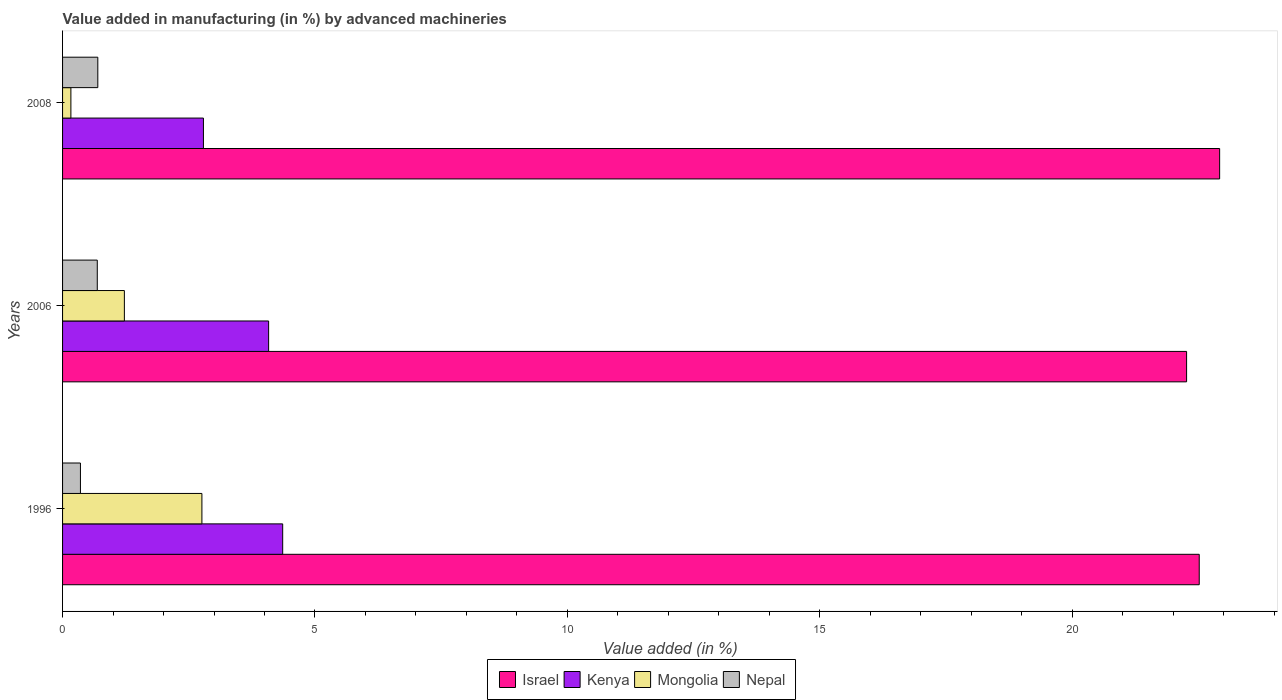How many groups of bars are there?
Your answer should be compact. 3. In how many cases, is the number of bars for a given year not equal to the number of legend labels?
Make the answer very short. 0. What is the percentage of value added in manufacturing by advanced machineries in Kenya in 2006?
Provide a short and direct response. 4.08. Across all years, what is the maximum percentage of value added in manufacturing by advanced machineries in Mongolia?
Your answer should be very brief. 2.76. Across all years, what is the minimum percentage of value added in manufacturing by advanced machineries in Mongolia?
Provide a succinct answer. 0.17. What is the total percentage of value added in manufacturing by advanced machineries in Mongolia in the graph?
Make the answer very short. 4.15. What is the difference between the percentage of value added in manufacturing by advanced machineries in Nepal in 1996 and that in 2006?
Ensure brevity in your answer.  -0.33. What is the difference between the percentage of value added in manufacturing by advanced machineries in Kenya in 1996 and the percentage of value added in manufacturing by advanced machineries in Nepal in 2008?
Your answer should be compact. 3.66. What is the average percentage of value added in manufacturing by advanced machineries in Mongolia per year?
Your answer should be very brief. 1.38. In the year 1996, what is the difference between the percentage of value added in manufacturing by advanced machineries in Israel and percentage of value added in manufacturing by advanced machineries in Kenya?
Provide a short and direct response. 18.16. What is the ratio of the percentage of value added in manufacturing by advanced machineries in Mongolia in 1996 to that in 2006?
Your answer should be very brief. 2.25. What is the difference between the highest and the second highest percentage of value added in manufacturing by advanced machineries in Nepal?
Your response must be concise. 0.01. What is the difference between the highest and the lowest percentage of value added in manufacturing by advanced machineries in Mongolia?
Your answer should be compact. 2.6. Is the sum of the percentage of value added in manufacturing by advanced machineries in Israel in 1996 and 2006 greater than the maximum percentage of value added in manufacturing by advanced machineries in Mongolia across all years?
Your response must be concise. Yes. What does the 1st bar from the top in 1996 represents?
Provide a short and direct response. Nepal. What does the 2nd bar from the bottom in 2006 represents?
Keep it short and to the point. Kenya. How many bars are there?
Provide a short and direct response. 12. Are all the bars in the graph horizontal?
Ensure brevity in your answer.  Yes. What is the difference between two consecutive major ticks on the X-axis?
Offer a terse response. 5. How many legend labels are there?
Your answer should be very brief. 4. What is the title of the graph?
Provide a short and direct response. Value added in manufacturing (in %) by advanced machineries. Does "Heavily indebted poor countries" appear as one of the legend labels in the graph?
Offer a terse response. No. What is the label or title of the X-axis?
Offer a terse response. Value added (in %). What is the Value added (in %) of Israel in 1996?
Provide a succinct answer. 22.52. What is the Value added (in %) in Kenya in 1996?
Your response must be concise. 4.36. What is the Value added (in %) of Mongolia in 1996?
Keep it short and to the point. 2.76. What is the Value added (in %) in Nepal in 1996?
Provide a succinct answer. 0.35. What is the Value added (in %) in Israel in 2006?
Provide a succinct answer. 22.27. What is the Value added (in %) in Kenya in 2006?
Provide a short and direct response. 4.08. What is the Value added (in %) of Mongolia in 2006?
Ensure brevity in your answer.  1.22. What is the Value added (in %) of Nepal in 2006?
Ensure brevity in your answer.  0.69. What is the Value added (in %) of Israel in 2008?
Offer a very short reply. 22.92. What is the Value added (in %) of Kenya in 2008?
Offer a terse response. 2.79. What is the Value added (in %) in Mongolia in 2008?
Offer a very short reply. 0.17. What is the Value added (in %) of Nepal in 2008?
Provide a short and direct response. 0.7. Across all years, what is the maximum Value added (in %) of Israel?
Keep it short and to the point. 22.92. Across all years, what is the maximum Value added (in %) in Kenya?
Your response must be concise. 4.36. Across all years, what is the maximum Value added (in %) in Mongolia?
Provide a short and direct response. 2.76. Across all years, what is the maximum Value added (in %) of Nepal?
Keep it short and to the point. 0.7. Across all years, what is the minimum Value added (in %) of Israel?
Ensure brevity in your answer.  22.27. Across all years, what is the minimum Value added (in %) in Kenya?
Your response must be concise. 2.79. Across all years, what is the minimum Value added (in %) in Mongolia?
Make the answer very short. 0.17. Across all years, what is the minimum Value added (in %) of Nepal?
Your answer should be very brief. 0.35. What is the total Value added (in %) in Israel in the graph?
Keep it short and to the point. 67.71. What is the total Value added (in %) in Kenya in the graph?
Your answer should be compact. 11.23. What is the total Value added (in %) of Mongolia in the graph?
Provide a succinct answer. 4.15. What is the total Value added (in %) of Nepal in the graph?
Your answer should be very brief. 1.74. What is the difference between the Value added (in %) in Israel in 1996 and that in 2006?
Your response must be concise. 0.25. What is the difference between the Value added (in %) in Kenya in 1996 and that in 2006?
Offer a terse response. 0.28. What is the difference between the Value added (in %) of Mongolia in 1996 and that in 2006?
Give a very brief answer. 1.54. What is the difference between the Value added (in %) of Nepal in 1996 and that in 2006?
Your response must be concise. -0.33. What is the difference between the Value added (in %) of Israel in 1996 and that in 2008?
Offer a very short reply. -0.4. What is the difference between the Value added (in %) of Kenya in 1996 and that in 2008?
Your answer should be compact. 1.57. What is the difference between the Value added (in %) of Mongolia in 1996 and that in 2008?
Provide a short and direct response. 2.6. What is the difference between the Value added (in %) of Nepal in 1996 and that in 2008?
Offer a very short reply. -0.34. What is the difference between the Value added (in %) of Israel in 2006 and that in 2008?
Your response must be concise. -0.65. What is the difference between the Value added (in %) of Kenya in 2006 and that in 2008?
Provide a succinct answer. 1.29. What is the difference between the Value added (in %) in Mongolia in 2006 and that in 2008?
Provide a succinct answer. 1.06. What is the difference between the Value added (in %) of Nepal in 2006 and that in 2008?
Ensure brevity in your answer.  -0.01. What is the difference between the Value added (in %) of Israel in 1996 and the Value added (in %) of Kenya in 2006?
Provide a succinct answer. 18.44. What is the difference between the Value added (in %) of Israel in 1996 and the Value added (in %) of Mongolia in 2006?
Provide a succinct answer. 21.29. What is the difference between the Value added (in %) in Israel in 1996 and the Value added (in %) in Nepal in 2006?
Your answer should be very brief. 21.83. What is the difference between the Value added (in %) of Kenya in 1996 and the Value added (in %) of Mongolia in 2006?
Make the answer very short. 3.14. What is the difference between the Value added (in %) in Kenya in 1996 and the Value added (in %) in Nepal in 2006?
Make the answer very short. 3.67. What is the difference between the Value added (in %) of Mongolia in 1996 and the Value added (in %) of Nepal in 2006?
Make the answer very short. 2.07. What is the difference between the Value added (in %) in Israel in 1996 and the Value added (in %) in Kenya in 2008?
Provide a short and direct response. 19.73. What is the difference between the Value added (in %) of Israel in 1996 and the Value added (in %) of Mongolia in 2008?
Make the answer very short. 22.35. What is the difference between the Value added (in %) of Israel in 1996 and the Value added (in %) of Nepal in 2008?
Keep it short and to the point. 21.82. What is the difference between the Value added (in %) in Kenya in 1996 and the Value added (in %) in Mongolia in 2008?
Provide a short and direct response. 4.2. What is the difference between the Value added (in %) of Kenya in 1996 and the Value added (in %) of Nepal in 2008?
Your response must be concise. 3.66. What is the difference between the Value added (in %) of Mongolia in 1996 and the Value added (in %) of Nepal in 2008?
Your answer should be very brief. 2.06. What is the difference between the Value added (in %) in Israel in 2006 and the Value added (in %) in Kenya in 2008?
Ensure brevity in your answer.  19.48. What is the difference between the Value added (in %) of Israel in 2006 and the Value added (in %) of Mongolia in 2008?
Your response must be concise. 22.1. What is the difference between the Value added (in %) of Israel in 2006 and the Value added (in %) of Nepal in 2008?
Offer a very short reply. 21.57. What is the difference between the Value added (in %) of Kenya in 2006 and the Value added (in %) of Mongolia in 2008?
Your response must be concise. 3.92. What is the difference between the Value added (in %) of Kenya in 2006 and the Value added (in %) of Nepal in 2008?
Your answer should be compact. 3.38. What is the difference between the Value added (in %) in Mongolia in 2006 and the Value added (in %) in Nepal in 2008?
Your answer should be very brief. 0.53. What is the average Value added (in %) in Israel per year?
Your answer should be compact. 22.57. What is the average Value added (in %) in Kenya per year?
Your answer should be compact. 3.74. What is the average Value added (in %) of Mongolia per year?
Make the answer very short. 1.38. What is the average Value added (in %) in Nepal per year?
Your answer should be very brief. 0.58. In the year 1996, what is the difference between the Value added (in %) of Israel and Value added (in %) of Kenya?
Provide a short and direct response. 18.16. In the year 1996, what is the difference between the Value added (in %) of Israel and Value added (in %) of Mongolia?
Offer a very short reply. 19.76. In the year 1996, what is the difference between the Value added (in %) in Israel and Value added (in %) in Nepal?
Your response must be concise. 22.16. In the year 1996, what is the difference between the Value added (in %) in Kenya and Value added (in %) in Mongolia?
Your answer should be compact. 1.6. In the year 1996, what is the difference between the Value added (in %) of Kenya and Value added (in %) of Nepal?
Keep it short and to the point. 4.01. In the year 1996, what is the difference between the Value added (in %) of Mongolia and Value added (in %) of Nepal?
Make the answer very short. 2.41. In the year 2006, what is the difference between the Value added (in %) in Israel and Value added (in %) in Kenya?
Make the answer very short. 18.19. In the year 2006, what is the difference between the Value added (in %) of Israel and Value added (in %) of Mongolia?
Provide a short and direct response. 21.04. In the year 2006, what is the difference between the Value added (in %) of Israel and Value added (in %) of Nepal?
Offer a very short reply. 21.58. In the year 2006, what is the difference between the Value added (in %) of Kenya and Value added (in %) of Mongolia?
Provide a short and direct response. 2.86. In the year 2006, what is the difference between the Value added (in %) of Kenya and Value added (in %) of Nepal?
Your answer should be very brief. 3.39. In the year 2006, what is the difference between the Value added (in %) in Mongolia and Value added (in %) in Nepal?
Your response must be concise. 0.54. In the year 2008, what is the difference between the Value added (in %) of Israel and Value added (in %) of Kenya?
Your answer should be very brief. 20.13. In the year 2008, what is the difference between the Value added (in %) in Israel and Value added (in %) in Mongolia?
Make the answer very short. 22.76. In the year 2008, what is the difference between the Value added (in %) of Israel and Value added (in %) of Nepal?
Offer a terse response. 22.22. In the year 2008, what is the difference between the Value added (in %) in Kenya and Value added (in %) in Mongolia?
Give a very brief answer. 2.63. In the year 2008, what is the difference between the Value added (in %) of Kenya and Value added (in %) of Nepal?
Make the answer very short. 2.09. In the year 2008, what is the difference between the Value added (in %) in Mongolia and Value added (in %) in Nepal?
Offer a terse response. -0.53. What is the ratio of the Value added (in %) in Israel in 1996 to that in 2006?
Your answer should be compact. 1.01. What is the ratio of the Value added (in %) in Kenya in 1996 to that in 2006?
Provide a short and direct response. 1.07. What is the ratio of the Value added (in %) in Mongolia in 1996 to that in 2006?
Offer a very short reply. 2.25. What is the ratio of the Value added (in %) of Nepal in 1996 to that in 2006?
Your answer should be very brief. 0.51. What is the ratio of the Value added (in %) in Israel in 1996 to that in 2008?
Your answer should be very brief. 0.98. What is the ratio of the Value added (in %) of Kenya in 1996 to that in 2008?
Provide a succinct answer. 1.56. What is the ratio of the Value added (in %) in Mongolia in 1996 to that in 2008?
Offer a very short reply. 16.73. What is the ratio of the Value added (in %) in Nepal in 1996 to that in 2008?
Keep it short and to the point. 0.51. What is the ratio of the Value added (in %) of Israel in 2006 to that in 2008?
Ensure brevity in your answer.  0.97. What is the ratio of the Value added (in %) of Kenya in 2006 to that in 2008?
Your response must be concise. 1.46. What is the ratio of the Value added (in %) of Mongolia in 2006 to that in 2008?
Your answer should be compact. 7.42. What is the ratio of the Value added (in %) in Nepal in 2006 to that in 2008?
Your response must be concise. 0.98. What is the difference between the highest and the second highest Value added (in %) of Israel?
Offer a very short reply. 0.4. What is the difference between the highest and the second highest Value added (in %) of Kenya?
Offer a terse response. 0.28. What is the difference between the highest and the second highest Value added (in %) of Mongolia?
Offer a very short reply. 1.54. What is the difference between the highest and the second highest Value added (in %) in Nepal?
Your answer should be very brief. 0.01. What is the difference between the highest and the lowest Value added (in %) in Israel?
Offer a terse response. 0.65. What is the difference between the highest and the lowest Value added (in %) in Kenya?
Give a very brief answer. 1.57. What is the difference between the highest and the lowest Value added (in %) of Mongolia?
Make the answer very short. 2.6. What is the difference between the highest and the lowest Value added (in %) in Nepal?
Offer a very short reply. 0.34. 